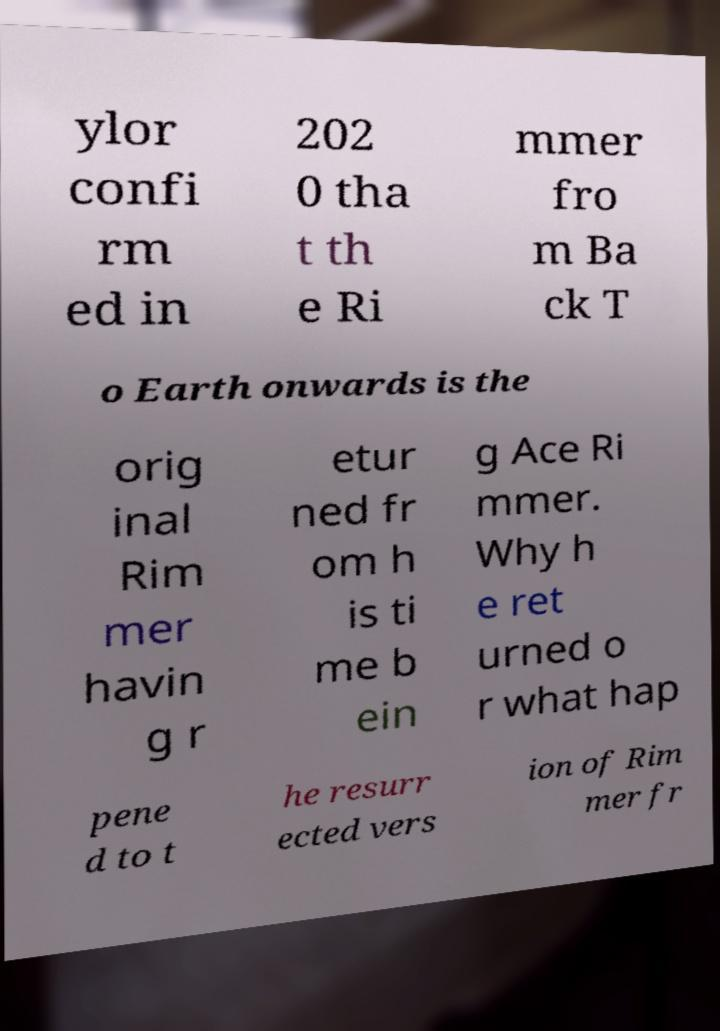For documentation purposes, I need the text within this image transcribed. Could you provide that? ylor confi rm ed in 202 0 tha t th e Ri mmer fro m Ba ck T o Earth onwards is the orig inal Rim mer havin g r etur ned fr om h is ti me b ein g Ace Ri mmer. Why h e ret urned o r what hap pene d to t he resurr ected vers ion of Rim mer fr 